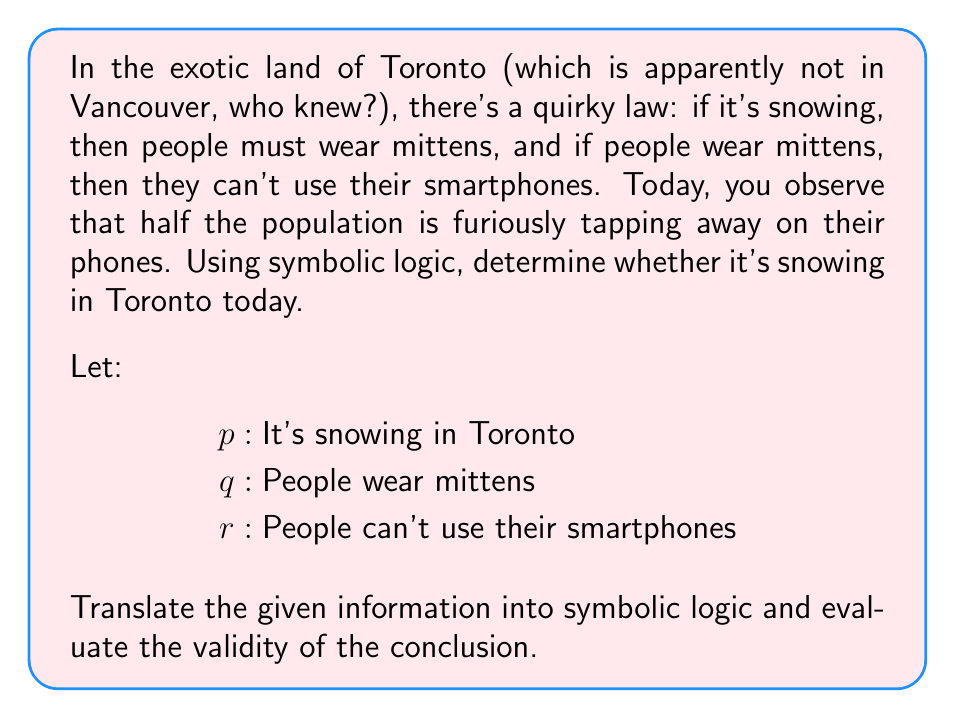What is the answer to this math problem? Let's break this down step-by-step:

1) First, let's translate the given laws into symbolic logic:
   - If it's snowing, then people must wear mittens: $p \rightarrow q$
   - If people wear mittens, then they can't use their smartphones: $q \rightarrow r$

2) We're also told that half the population is using their smartphones. This means that the statement "People can't use their smartphones" is false. In symbolic logic, we represent this as $\lnot r$.

3) Now, we can use the law of contrapositive to rewrite our second premise:
   $q \rightarrow r$ is logically equivalent to $\lnot r \rightarrow \lnot q$

4) We can now construct a chain of logical implications:
   $\lnot r \rightarrow \lnot q$ (from step 3)
   $\lnot q \rightarrow \lnot p$ (contrapositive of $p \rightarrow q$ from step 1)

5) Combining these using the transitive property of implication:
   $\lnot r \rightarrow \lnot p$

6) Since we know $\lnot r$ is true (people are using smartphones), we can apply modus ponens to conclude that $\lnot p$ must also be true.

7) $\lnot p$ means "It is not snowing in Toronto".

Therefore, based on the given information and logical deduction, we can conclude that it is not snowing in Toronto today.
Answer: It is not snowing in Toronto today. Symbolically: $\lnot p$ 